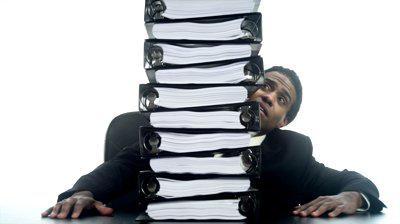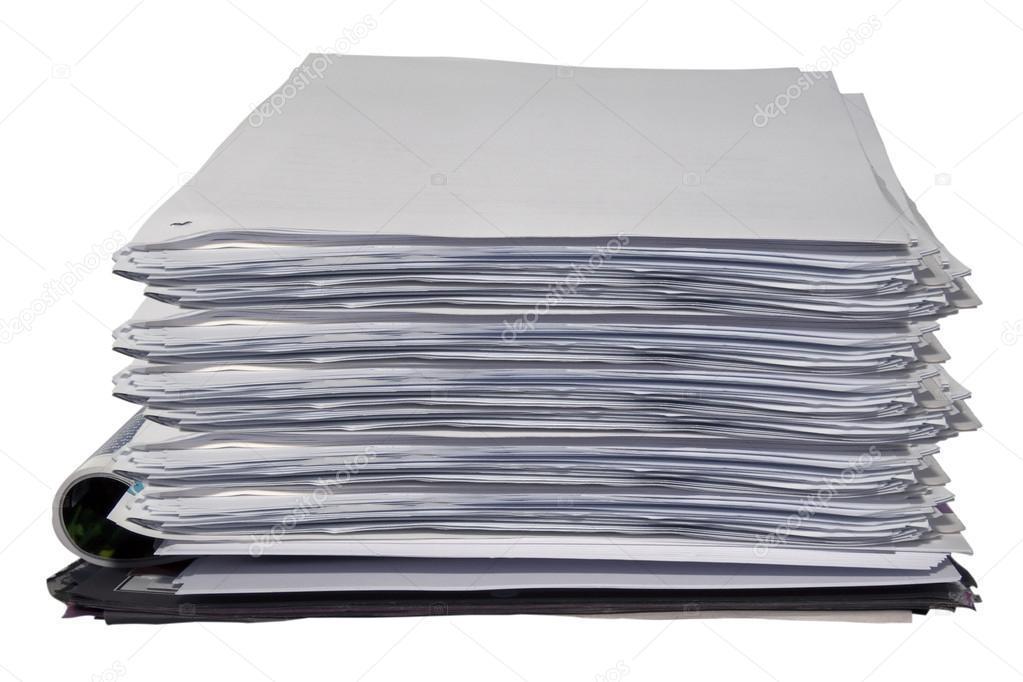The first image is the image on the left, the second image is the image on the right. Considering the images on both sides, is "The left image contains a person seated behind a stack of binders." valid? Answer yes or no. Yes. The first image is the image on the left, the second image is the image on the right. For the images displayed, is the sentence "A person is sitting behind a stack of binders in one of the images." factually correct? Answer yes or no. Yes. 